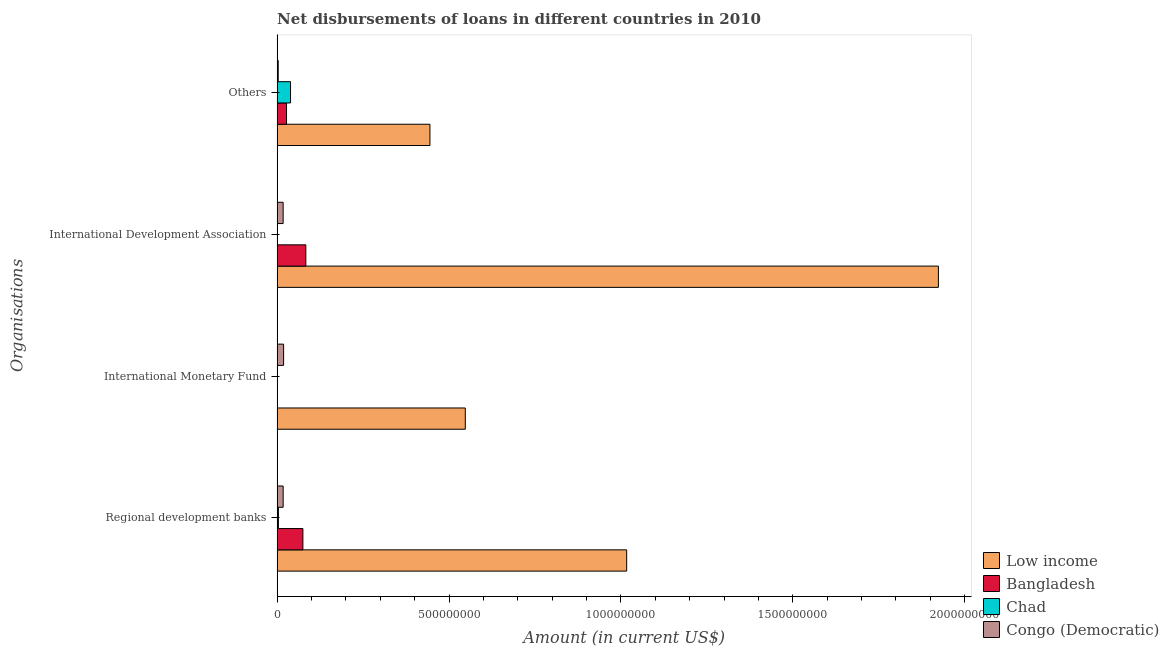How many different coloured bars are there?
Offer a very short reply. 4. Are the number of bars on each tick of the Y-axis equal?
Offer a terse response. No. How many bars are there on the 1st tick from the bottom?
Give a very brief answer. 4. What is the label of the 3rd group of bars from the top?
Offer a very short reply. International Monetary Fund. What is the amount of loan disimbursed by international development association in Bangladesh?
Your response must be concise. 8.35e+07. Across all countries, what is the maximum amount of loan disimbursed by international development association?
Provide a short and direct response. 1.92e+09. Across all countries, what is the minimum amount of loan disimbursed by regional development banks?
Your answer should be very brief. 3.76e+06. What is the total amount of loan disimbursed by international monetary fund in the graph?
Offer a very short reply. 5.66e+08. What is the difference between the amount of loan disimbursed by international development association in Bangladesh and that in Low income?
Ensure brevity in your answer.  -1.84e+09. What is the difference between the amount of loan disimbursed by regional development banks in Low income and the amount of loan disimbursed by international monetary fund in Chad?
Give a very brief answer. 1.02e+09. What is the average amount of loan disimbursed by international development association per country?
Provide a succinct answer. 5.06e+08. What is the difference between the amount of loan disimbursed by other organisations and amount of loan disimbursed by international development association in Bangladesh?
Offer a terse response. -5.61e+07. What is the ratio of the amount of loan disimbursed by international development association in Bangladesh to that in Congo (Democratic)?
Your answer should be compact. 4.77. Is the amount of loan disimbursed by other organisations in Congo (Democratic) less than that in Low income?
Ensure brevity in your answer.  Yes. Is the difference between the amount of loan disimbursed by regional development banks in Congo (Democratic) and Bangladesh greater than the difference between the amount of loan disimbursed by other organisations in Congo (Democratic) and Bangladesh?
Keep it short and to the point. No. What is the difference between the highest and the second highest amount of loan disimbursed by other organisations?
Provide a short and direct response. 4.06e+08. What is the difference between the highest and the lowest amount of loan disimbursed by international development association?
Offer a very short reply. 1.92e+09. Is the sum of the amount of loan disimbursed by regional development banks in Bangladesh and Low income greater than the maximum amount of loan disimbursed by other organisations across all countries?
Provide a succinct answer. Yes. Is it the case that in every country, the sum of the amount of loan disimbursed by regional development banks and amount of loan disimbursed by international monetary fund is greater than the sum of amount of loan disimbursed by other organisations and amount of loan disimbursed by international development association?
Your response must be concise. No. What is the difference between two consecutive major ticks on the X-axis?
Provide a succinct answer. 5.00e+08. Does the graph contain grids?
Keep it short and to the point. No. Where does the legend appear in the graph?
Your response must be concise. Bottom right. What is the title of the graph?
Your answer should be compact. Net disbursements of loans in different countries in 2010. What is the label or title of the X-axis?
Your response must be concise. Amount (in current US$). What is the label or title of the Y-axis?
Ensure brevity in your answer.  Organisations. What is the Amount (in current US$) in Low income in Regional development banks?
Offer a terse response. 1.02e+09. What is the Amount (in current US$) of Bangladesh in Regional development banks?
Ensure brevity in your answer.  7.50e+07. What is the Amount (in current US$) of Chad in Regional development banks?
Your response must be concise. 3.76e+06. What is the Amount (in current US$) in Congo (Democratic) in Regional development banks?
Provide a short and direct response. 1.75e+07. What is the Amount (in current US$) of Low income in International Monetary Fund?
Ensure brevity in your answer.  5.47e+08. What is the Amount (in current US$) of Bangladesh in International Monetary Fund?
Offer a very short reply. 0. What is the Amount (in current US$) of Congo (Democratic) in International Monetary Fund?
Offer a very short reply. 1.89e+07. What is the Amount (in current US$) of Low income in International Development Association?
Make the answer very short. 1.92e+09. What is the Amount (in current US$) of Bangladesh in International Development Association?
Make the answer very short. 8.35e+07. What is the Amount (in current US$) of Congo (Democratic) in International Development Association?
Your response must be concise. 1.75e+07. What is the Amount (in current US$) of Low income in Others?
Your answer should be compact. 4.45e+08. What is the Amount (in current US$) in Bangladesh in Others?
Your answer should be very brief. 2.74e+07. What is the Amount (in current US$) in Chad in Others?
Offer a very short reply. 3.90e+07. What is the Amount (in current US$) in Congo (Democratic) in Others?
Keep it short and to the point. 3.20e+06. Across all Organisations, what is the maximum Amount (in current US$) of Low income?
Ensure brevity in your answer.  1.92e+09. Across all Organisations, what is the maximum Amount (in current US$) in Bangladesh?
Provide a succinct answer. 8.35e+07. Across all Organisations, what is the maximum Amount (in current US$) in Chad?
Your answer should be compact. 3.90e+07. Across all Organisations, what is the maximum Amount (in current US$) in Congo (Democratic)?
Offer a very short reply. 1.89e+07. Across all Organisations, what is the minimum Amount (in current US$) of Low income?
Offer a terse response. 4.45e+08. Across all Organisations, what is the minimum Amount (in current US$) in Congo (Democratic)?
Keep it short and to the point. 3.20e+06. What is the total Amount (in current US$) of Low income in the graph?
Offer a very short reply. 3.93e+09. What is the total Amount (in current US$) of Bangladesh in the graph?
Keep it short and to the point. 1.86e+08. What is the total Amount (in current US$) in Chad in the graph?
Your answer should be compact. 4.28e+07. What is the total Amount (in current US$) of Congo (Democratic) in the graph?
Give a very brief answer. 5.71e+07. What is the difference between the Amount (in current US$) in Low income in Regional development banks and that in International Monetary Fund?
Make the answer very short. 4.69e+08. What is the difference between the Amount (in current US$) of Congo (Democratic) in Regional development banks and that in International Monetary Fund?
Provide a succinct answer. -1.34e+06. What is the difference between the Amount (in current US$) of Low income in Regional development banks and that in International Development Association?
Offer a very short reply. -9.07e+08. What is the difference between the Amount (in current US$) in Bangladesh in Regional development banks and that in International Development Association?
Offer a terse response. -8.53e+06. What is the difference between the Amount (in current US$) in Congo (Democratic) in Regional development banks and that in International Development Association?
Provide a short and direct response. 3.40e+04. What is the difference between the Amount (in current US$) of Low income in Regional development banks and that in Others?
Your response must be concise. 5.72e+08. What is the difference between the Amount (in current US$) in Bangladesh in Regional development banks and that in Others?
Your response must be concise. 4.76e+07. What is the difference between the Amount (in current US$) in Chad in Regional development banks and that in Others?
Your answer should be compact. -3.52e+07. What is the difference between the Amount (in current US$) of Congo (Democratic) in Regional development banks and that in Others?
Make the answer very short. 1.43e+07. What is the difference between the Amount (in current US$) of Low income in International Monetary Fund and that in International Development Association?
Provide a short and direct response. -1.38e+09. What is the difference between the Amount (in current US$) in Congo (Democratic) in International Monetary Fund and that in International Development Association?
Your response must be concise. 1.37e+06. What is the difference between the Amount (in current US$) of Low income in International Monetary Fund and that in Others?
Ensure brevity in your answer.  1.03e+08. What is the difference between the Amount (in current US$) of Congo (Democratic) in International Monetary Fund and that in Others?
Provide a short and direct response. 1.57e+07. What is the difference between the Amount (in current US$) of Low income in International Development Association and that in Others?
Provide a succinct answer. 1.48e+09. What is the difference between the Amount (in current US$) in Bangladesh in International Development Association and that in Others?
Make the answer very short. 5.61e+07. What is the difference between the Amount (in current US$) in Congo (Democratic) in International Development Association and that in Others?
Make the answer very short. 1.43e+07. What is the difference between the Amount (in current US$) in Low income in Regional development banks and the Amount (in current US$) in Congo (Democratic) in International Monetary Fund?
Your answer should be compact. 9.98e+08. What is the difference between the Amount (in current US$) of Bangladesh in Regional development banks and the Amount (in current US$) of Congo (Democratic) in International Monetary Fund?
Offer a terse response. 5.61e+07. What is the difference between the Amount (in current US$) of Chad in Regional development banks and the Amount (in current US$) of Congo (Democratic) in International Monetary Fund?
Your response must be concise. -1.51e+07. What is the difference between the Amount (in current US$) of Low income in Regional development banks and the Amount (in current US$) of Bangladesh in International Development Association?
Keep it short and to the point. 9.33e+08. What is the difference between the Amount (in current US$) in Low income in Regional development banks and the Amount (in current US$) in Congo (Democratic) in International Development Association?
Provide a succinct answer. 9.99e+08. What is the difference between the Amount (in current US$) of Bangladesh in Regional development banks and the Amount (in current US$) of Congo (Democratic) in International Development Association?
Keep it short and to the point. 5.75e+07. What is the difference between the Amount (in current US$) in Chad in Regional development banks and the Amount (in current US$) in Congo (Democratic) in International Development Association?
Your response must be concise. -1.37e+07. What is the difference between the Amount (in current US$) of Low income in Regional development banks and the Amount (in current US$) of Bangladesh in Others?
Keep it short and to the point. 9.89e+08. What is the difference between the Amount (in current US$) of Low income in Regional development banks and the Amount (in current US$) of Chad in Others?
Your answer should be very brief. 9.78e+08. What is the difference between the Amount (in current US$) in Low income in Regional development banks and the Amount (in current US$) in Congo (Democratic) in Others?
Provide a succinct answer. 1.01e+09. What is the difference between the Amount (in current US$) of Bangladesh in Regional development banks and the Amount (in current US$) of Chad in Others?
Your answer should be very brief. 3.60e+07. What is the difference between the Amount (in current US$) in Bangladesh in Regional development banks and the Amount (in current US$) in Congo (Democratic) in Others?
Your response must be concise. 7.18e+07. What is the difference between the Amount (in current US$) of Chad in Regional development banks and the Amount (in current US$) of Congo (Democratic) in Others?
Offer a very short reply. 5.63e+05. What is the difference between the Amount (in current US$) of Low income in International Monetary Fund and the Amount (in current US$) of Bangladesh in International Development Association?
Provide a short and direct response. 4.64e+08. What is the difference between the Amount (in current US$) of Low income in International Monetary Fund and the Amount (in current US$) of Congo (Democratic) in International Development Association?
Your answer should be compact. 5.30e+08. What is the difference between the Amount (in current US$) of Low income in International Monetary Fund and the Amount (in current US$) of Bangladesh in Others?
Offer a very short reply. 5.20e+08. What is the difference between the Amount (in current US$) in Low income in International Monetary Fund and the Amount (in current US$) in Chad in Others?
Ensure brevity in your answer.  5.08e+08. What is the difference between the Amount (in current US$) of Low income in International Monetary Fund and the Amount (in current US$) of Congo (Democratic) in Others?
Offer a very short reply. 5.44e+08. What is the difference between the Amount (in current US$) of Low income in International Development Association and the Amount (in current US$) of Bangladesh in Others?
Offer a terse response. 1.90e+09. What is the difference between the Amount (in current US$) of Low income in International Development Association and the Amount (in current US$) of Chad in Others?
Make the answer very short. 1.88e+09. What is the difference between the Amount (in current US$) of Low income in International Development Association and the Amount (in current US$) of Congo (Democratic) in Others?
Your answer should be very brief. 1.92e+09. What is the difference between the Amount (in current US$) of Bangladesh in International Development Association and the Amount (in current US$) of Chad in Others?
Provide a short and direct response. 4.45e+07. What is the difference between the Amount (in current US$) in Bangladesh in International Development Association and the Amount (in current US$) in Congo (Democratic) in Others?
Offer a terse response. 8.03e+07. What is the average Amount (in current US$) in Low income per Organisations?
Provide a succinct answer. 9.83e+08. What is the average Amount (in current US$) of Bangladesh per Organisations?
Keep it short and to the point. 4.65e+07. What is the average Amount (in current US$) of Chad per Organisations?
Your answer should be compact. 1.07e+07. What is the average Amount (in current US$) of Congo (Democratic) per Organisations?
Provide a short and direct response. 1.43e+07. What is the difference between the Amount (in current US$) of Low income and Amount (in current US$) of Bangladesh in Regional development banks?
Provide a short and direct response. 9.42e+08. What is the difference between the Amount (in current US$) of Low income and Amount (in current US$) of Chad in Regional development banks?
Give a very brief answer. 1.01e+09. What is the difference between the Amount (in current US$) in Low income and Amount (in current US$) in Congo (Democratic) in Regional development banks?
Make the answer very short. 9.99e+08. What is the difference between the Amount (in current US$) of Bangladesh and Amount (in current US$) of Chad in Regional development banks?
Make the answer very short. 7.12e+07. What is the difference between the Amount (in current US$) in Bangladesh and Amount (in current US$) in Congo (Democratic) in Regional development banks?
Keep it short and to the point. 5.74e+07. What is the difference between the Amount (in current US$) in Chad and Amount (in current US$) in Congo (Democratic) in Regional development banks?
Your response must be concise. -1.38e+07. What is the difference between the Amount (in current US$) of Low income and Amount (in current US$) of Congo (Democratic) in International Monetary Fund?
Offer a terse response. 5.28e+08. What is the difference between the Amount (in current US$) of Low income and Amount (in current US$) of Bangladesh in International Development Association?
Make the answer very short. 1.84e+09. What is the difference between the Amount (in current US$) of Low income and Amount (in current US$) of Congo (Democratic) in International Development Association?
Keep it short and to the point. 1.91e+09. What is the difference between the Amount (in current US$) in Bangladesh and Amount (in current US$) in Congo (Democratic) in International Development Association?
Offer a terse response. 6.60e+07. What is the difference between the Amount (in current US$) of Low income and Amount (in current US$) of Bangladesh in Others?
Ensure brevity in your answer.  4.17e+08. What is the difference between the Amount (in current US$) in Low income and Amount (in current US$) in Chad in Others?
Your answer should be very brief. 4.06e+08. What is the difference between the Amount (in current US$) in Low income and Amount (in current US$) in Congo (Democratic) in Others?
Ensure brevity in your answer.  4.41e+08. What is the difference between the Amount (in current US$) in Bangladesh and Amount (in current US$) in Chad in Others?
Ensure brevity in your answer.  -1.16e+07. What is the difference between the Amount (in current US$) of Bangladesh and Amount (in current US$) of Congo (Democratic) in Others?
Offer a terse response. 2.42e+07. What is the difference between the Amount (in current US$) of Chad and Amount (in current US$) of Congo (Democratic) in Others?
Ensure brevity in your answer.  3.58e+07. What is the ratio of the Amount (in current US$) of Low income in Regional development banks to that in International Monetary Fund?
Offer a terse response. 1.86. What is the ratio of the Amount (in current US$) of Congo (Democratic) in Regional development banks to that in International Monetary Fund?
Ensure brevity in your answer.  0.93. What is the ratio of the Amount (in current US$) in Low income in Regional development banks to that in International Development Association?
Provide a short and direct response. 0.53. What is the ratio of the Amount (in current US$) of Bangladesh in Regional development banks to that in International Development Association?
Give a very brief answer. 0.9. What is the ratio of the Amount (in current US$) of Low income in Regional development banks to that in Others?
Make the answer very short. 2.29. What is the ratio of the Amount (in current US$) of Bangladesh in Regional development banks to that in Others?
Offer a very short reply. 2.74. What is the ratio of the Amount (in current US$) of Chad in Regional development banks to that in Others?
Provide a short and direct response. 0.1. What is the ratio of the Amount (in current US$) in Congo (Democratic) in Regional development banks to that in Others?
Offer a very short reply. 5.48. What is the ratio of the Amount (in current US$) of Low income in International Monetary Fund to that in International Development Association?
Keep it short and to the point. 0.28. What is the ratio of the Amount (in current US$) in Congo (Democratic) in International Monetary Fund to that in International Development Association?
Keep it short and to the point. 1.08. What is the ratio of the Amount (in current US$) in Low income in International Monetary Fund to that in Others?
Offer a very short reply. 1.23. What is the ratio of the Amount (in current US$) in Congo (Democratic) in International Monetary Fund to that in Others?
Offer a terse response. 5.89. What is the ratio of the Amount (in current US$) in Low income in International Development Association to that in Others?
Keep it short and to the point. 4.33. What is the ratio of the Amount (in current US$) of Bangladesh in International Development Association to that in Others?
Give a very brief answer. 3.05. What is the ratio of the Amount (in current US$) of Congo (Democratic) in International Development Association to that in Others?
Keep it short and to the point. 5.47. What is the difference between the highest and the second highest Amount (in current US$) of Low income?
Your answer should be very brief. 9.07e+08. What is the difference between the highest and the second highest Amount (in current US$) of Bangladesh?
Offer a very short reply. 8.53e+06. What is the difference between the highest and the second highest Amount (in current US$) of Congo (Democratic)?
Provide a succinct answer. 1.34e+06. What is the difference between the highest and the lowest Amount (in current US$) in Low income?
Offer a terse response. 1.48e+09. What is the difference between the highest and the lowest Amount (in current US$) in Bangladesh?
Provide a short and direct response. 8.35e+07. What is the difference between the highest and the lowest Amount (in current US$) in Chad?
Make the answer very short. 3.90e+07. What is the difference between the highest and the lowest Amount (in current US$) of Congo (Democratic)?
Keep it short and to the point. 1.57e+07. 